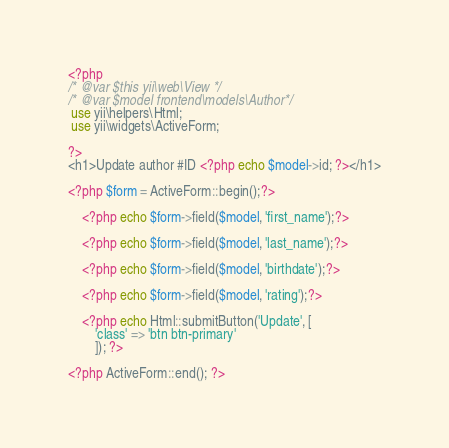Convert code to text. <code><loc_0><loc_0><loc_500><loc_500><_PHP_><?php
/* @var $this yii\web\View */
/* @var $model frontend\models\Author*/
 use yii\helpers\Html;
 use yii\widgets\ActiveForm;
 
?>
<h1>Update author #ID <?php echo $model->id; ?></h1>

<?php $form = ActiveForm::begin();?>
    
    <?php echo $form->field($model, 'first_name');?>

    <?php echo $form->field($model, 'last_name');?>

    <?php echo $form->field($model, 'birthdate');?>

    <?php echo $form->field($model, 'rating');?>

    <?php echo Html::submitButton('Update', [
        'class' => 'btn btn-primary'
        ]); ?>

<?php ActiveForm::end(); ?></code> 